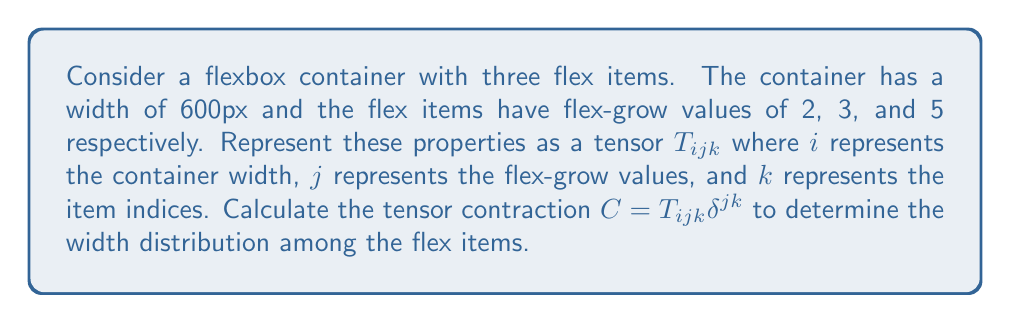Help me with this question. 1. First, let's represent the flexbox properties as a tensor:

   $$T_{ijk} = \begin{bmatrix}
   600 & 0 & 0 \\
   0 & 2 & 0 \\
   0 & 0 & 3 \\
   0 & 0 & 5
   \end{bmatrix}$$

2. The Kronecker delta $\delta^{jk}$ is defined as:
   $$\delta^{jk} = \begin{cases}
   1 & \text{if } j = k \\
   0 & \text{otherwise}
   \end{cases}$$

3. Performing the tensor contraction $C = T_{ijk} \delta^{jk}$:
   $$C_i = \sum_{j,k} T_{ijk} \delta^{jk} = T_{i11} + T_{i22} + T_{i33}$$

4. Calculating the components of $C_i$:
   $$C_1 = 600 + 0 + 0 = 600$$
   $$C_2 = 0 + 2 + 0 = 2$$
   $$C_3 = 0 + 0 + 3 = 3$$
   $$C_4 = 0 + 0 + 5 = 5$$

5. The resulting vector $C_i$ represents the container width and the flex-grow values:
   $$C_i = [600, 2, 3, 5]$$

6. To calculate the width distribution, we need to divide the available space proportionally:
   Total flex-grow sum: $2 + 3 + 5 = 10$
   Available space: $600\text{px}$

7. Width for each item:
   Item 1: $600 \times (2/10) = 120\text{px}$
   Item 2: $600 \times (3/10) = 180\text{px}$
   Item 3: $600 \times (5/10) = 300\text{px}$

Therefore, the width distribution among the flex items is [120px, 180px, 300px].
Answer: [120px, 180px, 300px] 